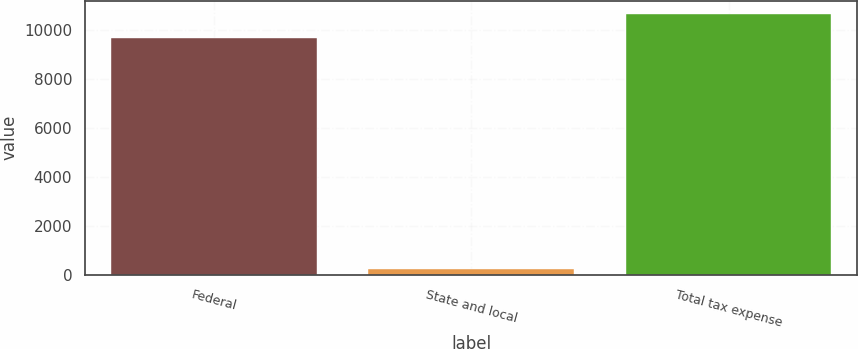<chart> <loc_0><loc_0><loc_500><loc_500><bar_chart><fcel>Federal<fcel>State and local<fcel>Total tax expense<nl><fcel>9661<fcel>225<fcel>10652.2<nl></chart> 